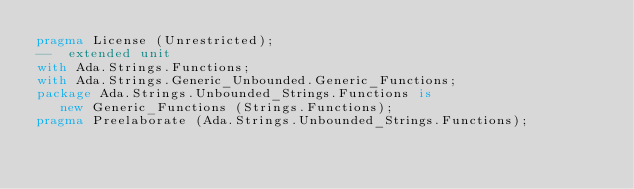<code> <loc_0><loc_0><loc_500><loc_500><_Ada_>pragma License (Unrestricted);
--  extended unit
with Ada.Strings.Functions;
with Ada.Strings.Generic_Unbounded.Generic_Functions;
package Ada.Strings.Unbounded_Strings.Functions is
   new Generic_Functions (Strings.Functions);
pragma Preelaborate (Ada.Strings.Unbounded_Strings.Functions);
</code> 